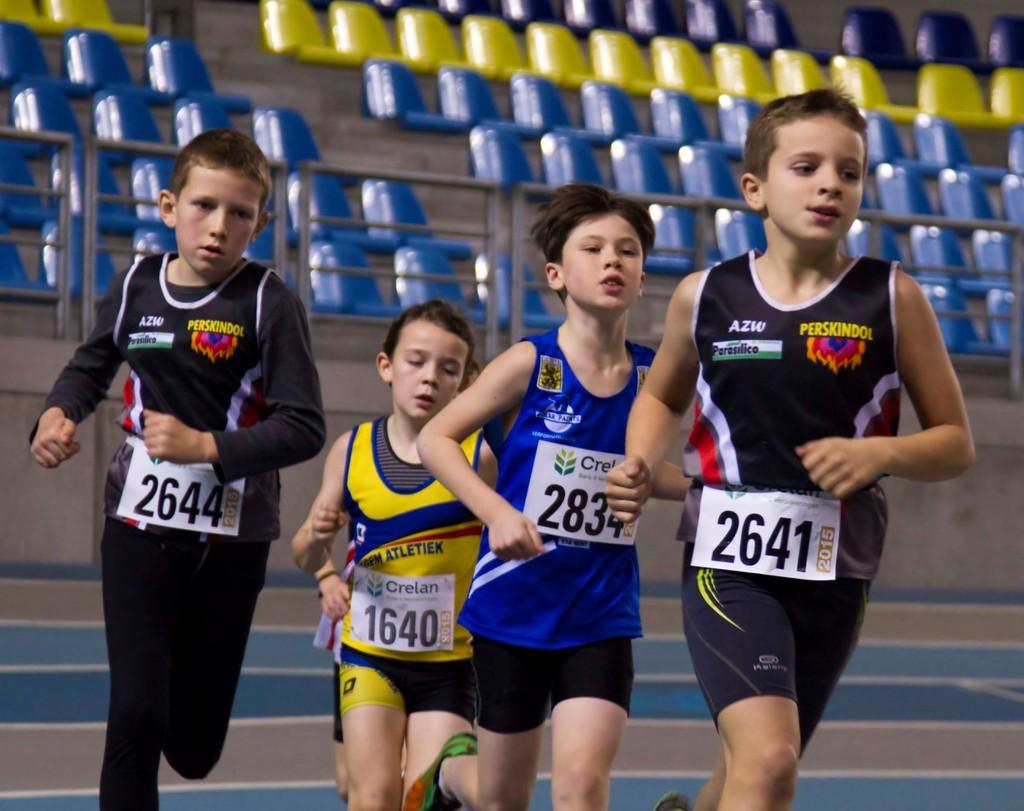How many people are in the image? There are four people in the image. What are the people doing in the image? The people are running. What can be observed about the clothing of the people in the image? The people are wearing different color dresses, and stickers are attached to their dresses. What can be seen in the background of the image? There are blue and yellow color chairs visible in the background. What type of government is depicted in the image? There is no depiction of a government in the image; it features four people running and wearing different color dresses with stickers. Can you tell me how many forks are visible in the image? There are no forks present in the image. 